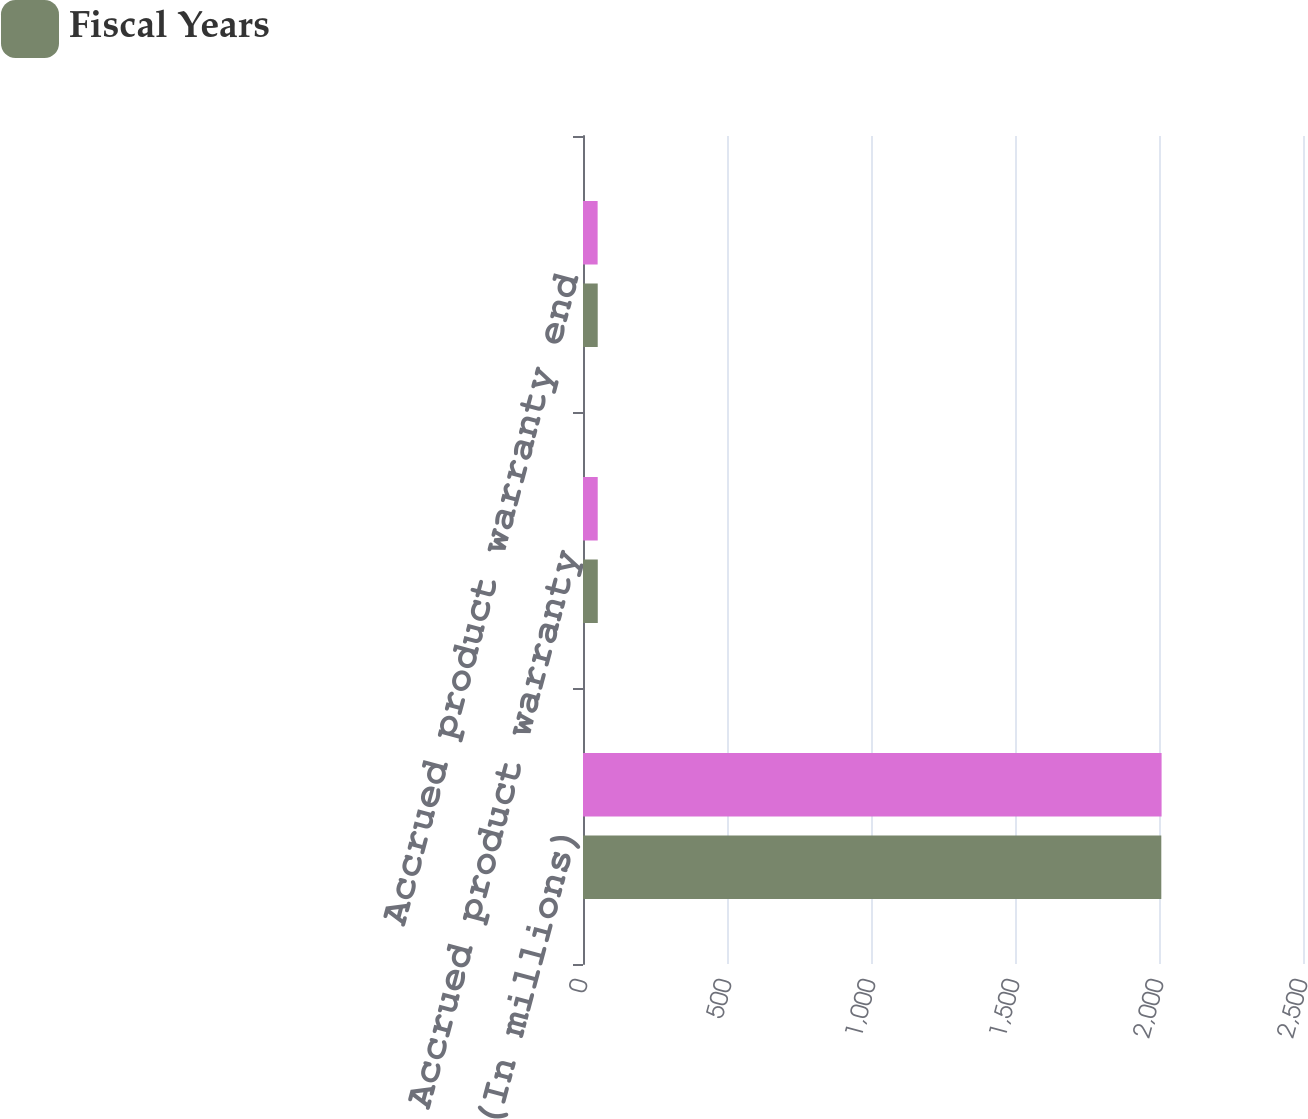Convert chart. <chart><loc_0><loc_0><loc_500><loc_500><stacked_bar_chart><ecel><fcel>(In millions)<fcel>Accrued product warranty<fcel>Accrued product warranty end<nl><fcel>nan<fcel>2009<fcel>51.1<fcel>50.8<nl><fcel>Fiscal Years<fcel>2008<fcel>51.3<fcel>51.1<nl></chart> 